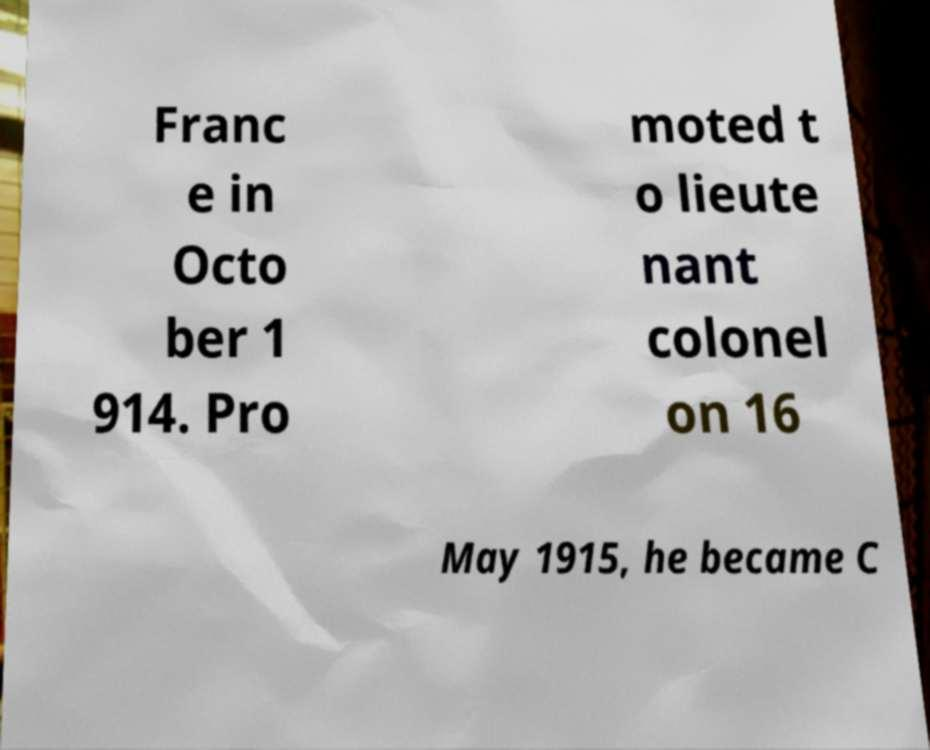Please read and relay the text visible in this image. What does it say? Franc e in Octo ber 1 914. Pro moted t o lieute nant colonel on 16 May 1915, he became C 